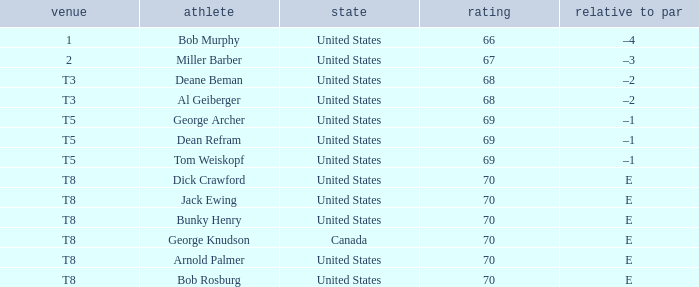Where did Bob Murphy of the United States place? 1.0. 